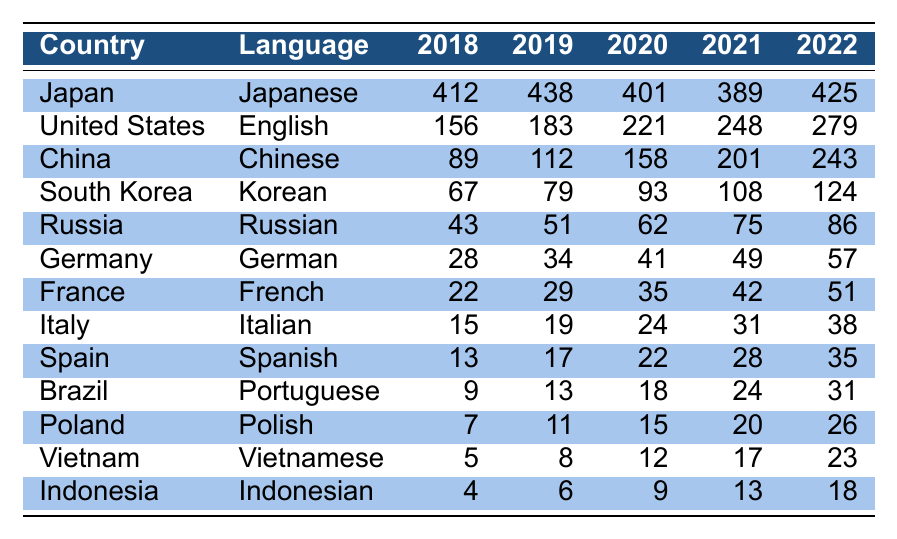What country had the highest number of visual novel releases in 2022? Japan had the highest number of releases with 425 visual novels in 2022. This is evident from the table where Japan is listed at the top with its corresponding value for 2022.
Answer: Japan In which year did the United States see the most significant increase in visual novel releases? The United States showed the most significant increase from 2018 to 2019, with an increase of 27 releases (from 156 to 183). This is the highest increase over any single year within the five years presented.
Answer: 2019 What was the total number of visual novel releases from China in 2020 and 2021 combined? Adding the values for China from 2020 and 2021, we calculate 158 (2020) + 201 (2021) = 359. Thus, the total number is 359.
Answer: 359 How many more visual novel releases did South Korea have in 2022 compared to 2018? South Korea had 124 releases in 2022 and 67 in 2018. The difference is 124 - 67 = 57. Therefore, there were 57 more releases in 2022 compared to 2018.
Answer: 57 Is it true that Germany had more visual novel releases in 2021 than in 2019? No, this is false. Germany had 49 releases in 2021 and 34 in 2019, which confirms that the number increased. However, the framing of the question as if it asked if the number was lower is what makes it false.
Answer: No What is the average number of visual novel releases for Italy over the five years? To find the average for Italy, sum the releases from 2018 to 2022 (15 + 19 + 24 + 31 + 38 = 127) and divide by the number of years (5). Thus, the average is 127 / 5 = 25.4.
Answer: 25.4 Which language had the second highest total number of visual novel releases in 2022? In 2022, Chinese (243) had the second highest total after Japanese (425). This is derived from comparing the total releases per language for that year.
Answer: Chinese How many countries had visual novel releases in the table? There are a total of 13 countries listed in the table that had visual novel releases, as counted in the "Country" column.
Answer: 13 What was the change in the number of visual novel releases for Russia from 2018 to 2022? Russia's releases rose from 43 in 2018 to 86 in 2022. The change is 86 - 43 = 43, indicating that Russia's number doubled over the five years.
Answer: 43 Which countries showed a decreasing trend in visual novel releases from 2018 to 2021? Japan and Germany both showed a decreasing trend in releases, dropping from 412 to 389 and from 28 to 49, respectively, through the years up to 2021 as per the table values.
Answer: Japan and Germany What is the total number of visual novel releases in 2019 across all countries? To find the total for 2019, simply sum the values for 2019 from each country: 438 + 183 + 112 + 79 + 51 + 34 + 29 + 19 + 17 + 13 + 11 + 8 + 6 =  962. Hence, the total is 962.
Answer: 962 